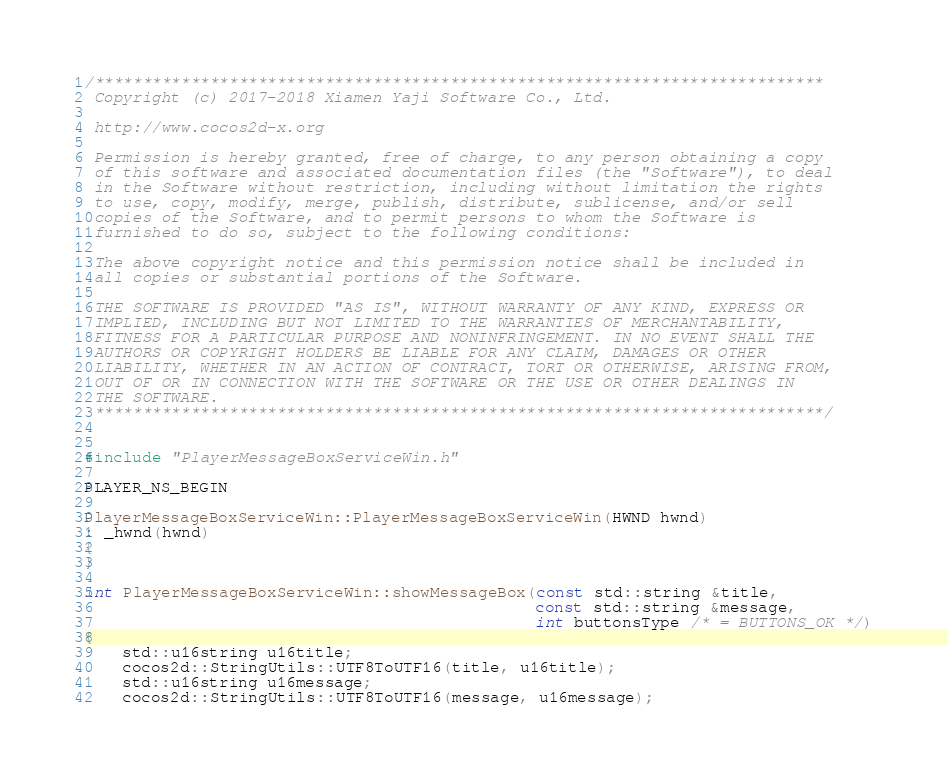<code> <loc_0><loc_0><loc_500><loc_500><_C++_>/****************************************************************************
 Copyright (c) 2017-2018 Xiamen Yaji Software Co., Ltd.
 
 http://www.cocos2d-x.org
 
 Permission is hereby granted, free of charge, to any person obtaining a copy
 of this software and associated documentation files (the "Software"), to deal
 in the Software without restriction, including without limitation the rights
 to use, copy, modify, merge, publish, distribute, sublicense, and/or sell
 copies of the Software, and to permit persons to whom the Software is
 furnished to do so, subject to the following conditions:
 
 The above copyright notice and this permission notice shall be included in
 all copies or substantial portions of the Software.
 
 THE SOFTWARE IS PROVIDED "AS IS", WITHOUT WARRANTY OF ANY KIND, EXPRESS OR
 IMPLIED, INCLUDING BUT NOT LIMITED TO THE WARRANTIES OF MERCHANTABILITY,
 FITNESS FOR A PARTICULAR PURPOSE AND NONINFRINGEMENT. IN NO EVENT SHALL THE
 AUTHORS OR COPYRIGHT HOLDERS BE LIABLE FOR ANY CLAIM, DAMAGES OR OTHER
 LIABILITY, WHETHER IN AN ACTION OF CONTRACT, TORT OR OTHERWISE, ARISING FROM,
 OUT OF OR IN CONNECTION WITH THE SOFTWARE OR THE USE OR OTHER DEALINGS IN
 THE SOFTWARE.
 ****************************************************************************/


#include "PlayerMessageBoxServiceWin.h"

PLAYER_NS_BEGIN

PlayerMessageBoxServiceWin::PlayerMessageBoxServiceWin(HWND hwnd)
: _hwnd(hwnd)
{
}

int PlayerMessageBoxServiceWin::showMessageBox(const std::string &title,
                                               const std::string &message,
                                               int buttonsType /* = BUTTONS_OK */)
{
    std::u16string u16title;
    cocos2d::StringUtils::UTF8ToUTF16(title, u16title);
    std::u16string u16message;
    cocos2d::StringUtils::UTF8ToUTF16(message, u16message);
</code> 